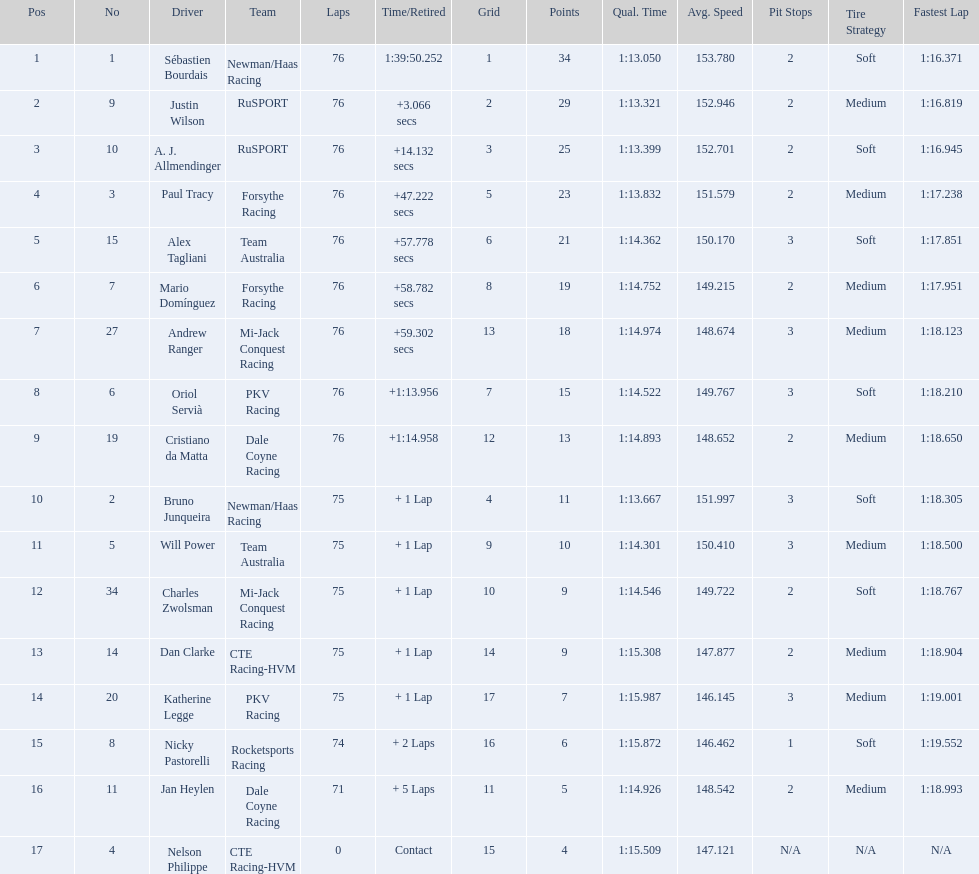What was the total points that canada earned together? 62. 